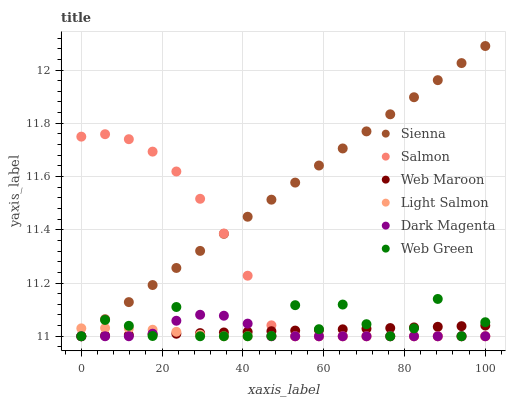Does Light Salmon have the minimum area under the curve?
Answer yes or no. Yes. Does Sienna have the maximum area under the curve?
Answer yes or no. Yes. Does Dark Magenta have the minimum area under the curve?
Answer yes or no. No. Does Dark Magenta have the maximum area under the curve?
Answer yes or no. No. Is Web Maroon the smoothest?
Answer yes or no. Yes. Is Web Green the roughest?
Answer yes or no. Yes. Is Dark Magenta the smoothest?
Answer yes or no. No. Is Dark Magenta the roughest?
Answer yes or no. No. Does Light Salmon have the lowest value?
Answer yes or no. Yes. Does Sienna have the highest value?
Answer yes or no. Yes. Does Dark Magenta have the highest value?
Answer yes or no. No. Does Web Green intersect Light Salmon?
Answer yes or no. Yes. Is Web Green less than Light Salmon?
Answer yes or no. No. Is Web Green greater than Light Salmon?
Answer yes or no. No. 